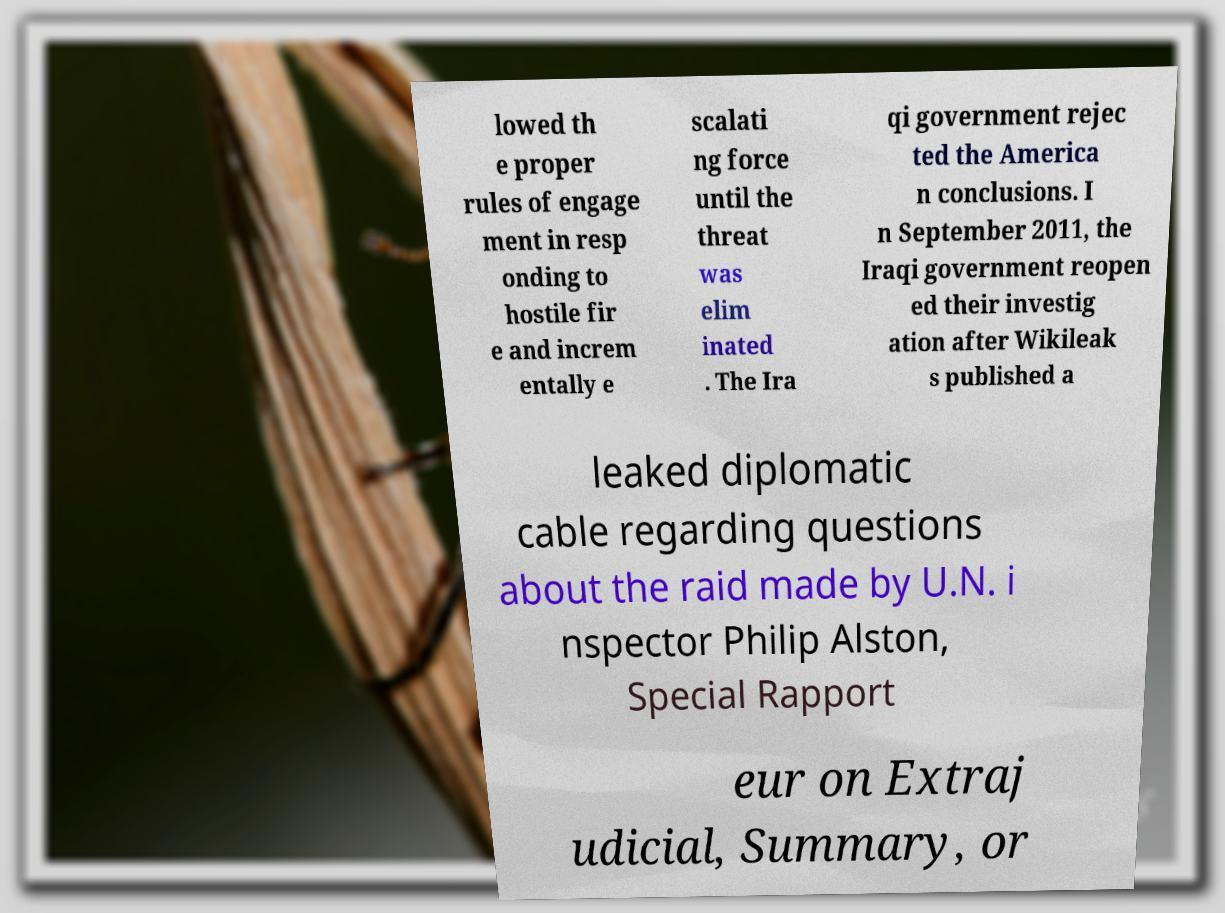Please identify and transcribe the text found in this image. lowed th e proper rules of engage ment in resp onding to hostile fir e and increm entally e scalati ng force until the threat was elim inated . The Ira qi government rejec ted the America n conclusions. I n September 2011, the Iraqi government reopen ed their investig ation after Wikileak s published a leaked diplomatic cable regarding questions about the raid made by U.N. i nspector Philip Alston, Special Rapport eur on Extraj udicial, Summary, or 